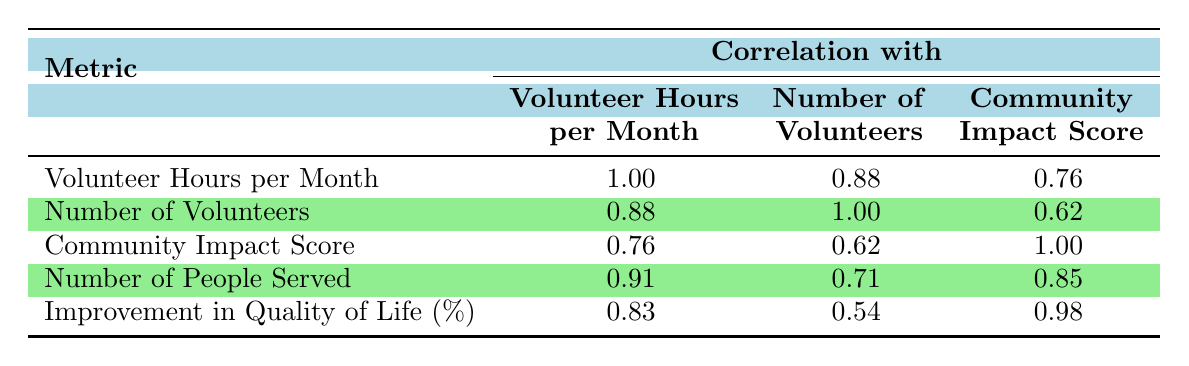What is the correlation between volunteer hours per month and the number of volunteers? The correlation value for volunteer hours per month and the number of volunteers can be found in the table under the corresponding row and column intersection. Specifically, it is listed as 0.88.
Answer: 0.88 Which metric has the highest correlation with the community impact score? To find the metric that correlates highest with the community impact score, look at the correlation values in the community impact score column. The highest value is 0.98, which corresponds to the improvement in quality of life percentage.
Answer: Improvement in quality of life (%) Is there a strong correlation between the number of people served and volunteer hours per month? The correlation between the number of people served and volunteer hours per month is 0.91, which is considered a strong correlation as it is close to 1.
Answer: Yes What is the average correlation between volunteer hours per month and all other listed metrics? Calculate the average by taking the sum of the correlation values for volunteer hours per month, which are 1.00, 0.88, 0.76, 0.91, and 0.83. The sum is 4.38 and dividing it by the number of metrics (4) gives an average of 1.09. Thus, the average correlation rounded off is 0.87.
Answer: 0.87 Do the number of volunteers and the community impact score have a weak or moderate correlation? The correlation value between the number of volunteers and the community impact score is 0.62. This value indicates a moderate correlation, as it is below 0.7 but above 0.4.
Answer: Moderate correlation What is the difference in correlation between the number of volunteers and the number of people served? The correlation value for the number of volunteers is 0.62 and for the number of people served it is 0.85. The difference can be calculated as 0.85 - 0.62 = 0.23.
Answer: 0.23 Is the correlation between volunteer hours per month and community impact score higher than that for the number of volunteers and community impact score? The correlation between volunteer hours per month and community impact score is 0.76, while that between the number of volunteers and community impact score is 0.62. Since 0.76 is greater than 0.62, the answer is yes.
Answer: Yes What is the correlation value for improvement in quality of life percentage with number of volunteers? The corresponding correlation value can be found in the table where the improvement in quality of life percentage intersects with the number of volunteers. It is noted as 0.54.
Answer: 0.54 